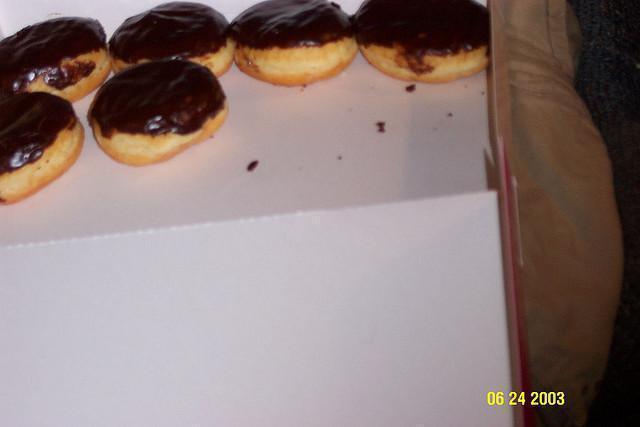How many donuts can be seen?
Give a very brief answer. 6. How many people here are squatting low to the ground?
Give a very brief answer. 0. 